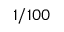<formula> <loc_0><loc_0><loc_500><loc_500>1 / 1 0 0</formula> 